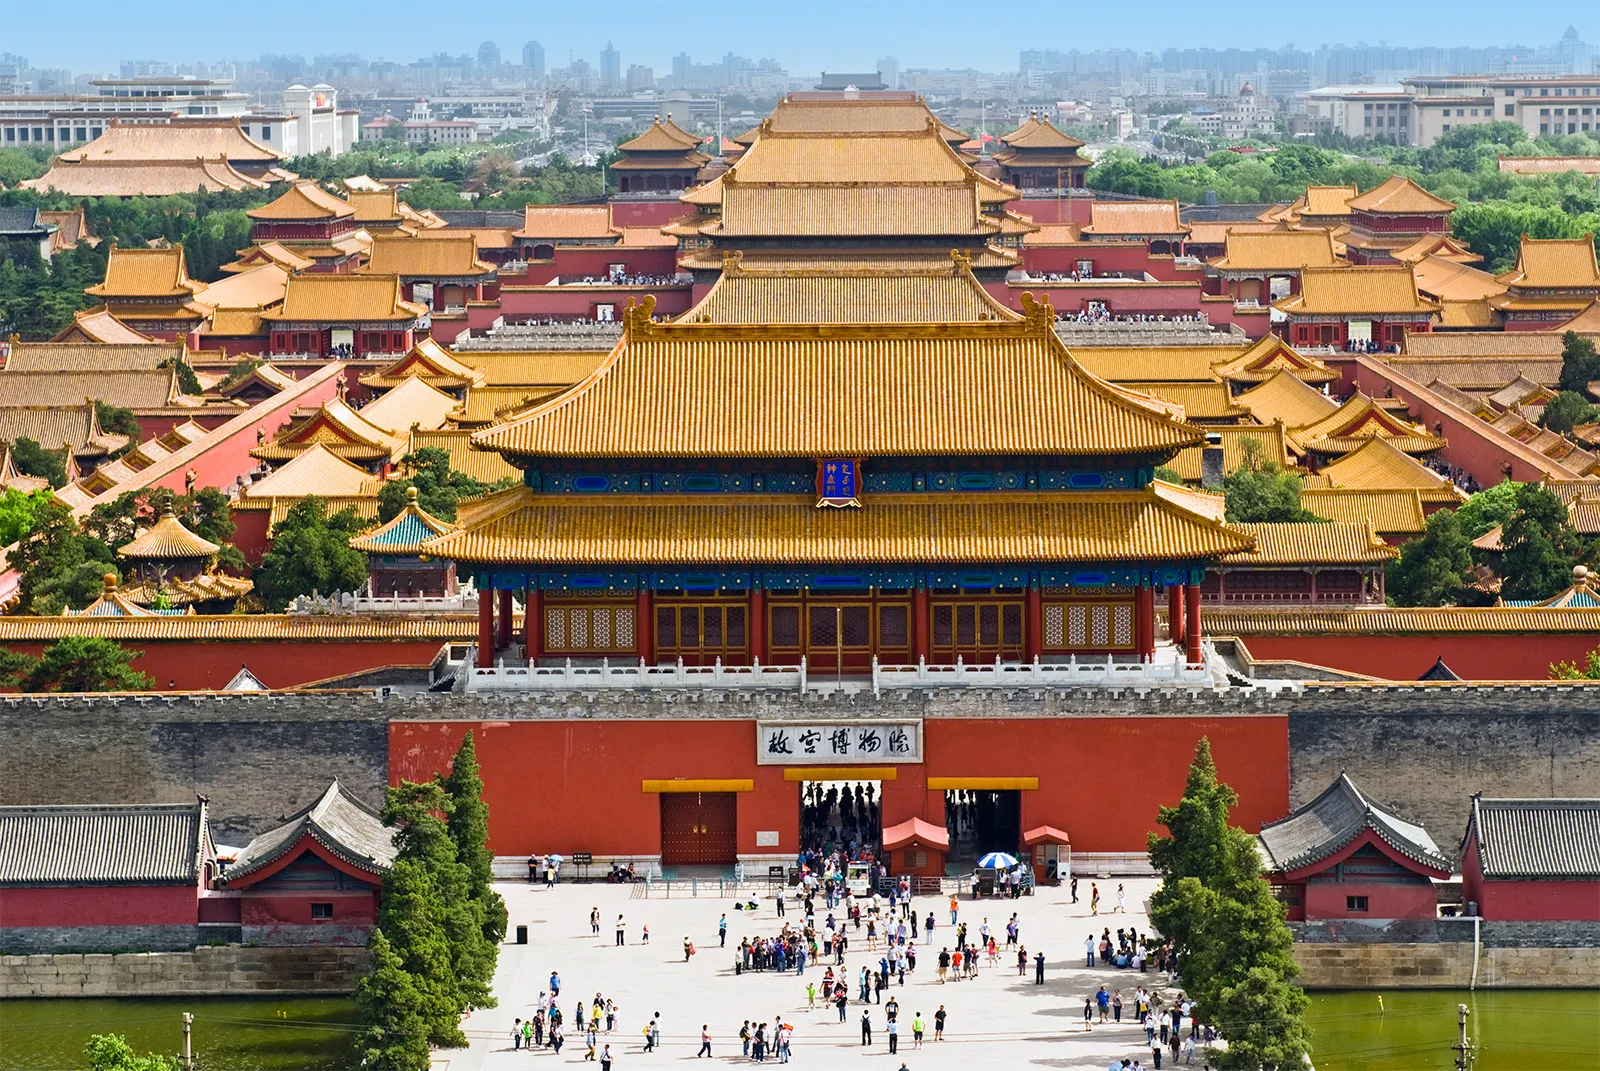What is the significance of the color scheme in the Forbidden City's architecture? The Forbidden City's dominant red and gold color palette holds deep cultural significance in Chinese culture. Red is traditionally associated with good fortune, happiness, and protection, while gold symbolizes wealth and power. This combination not only creates a striking visual impact but also reflects the supreme status of the emperor in imperial China. 